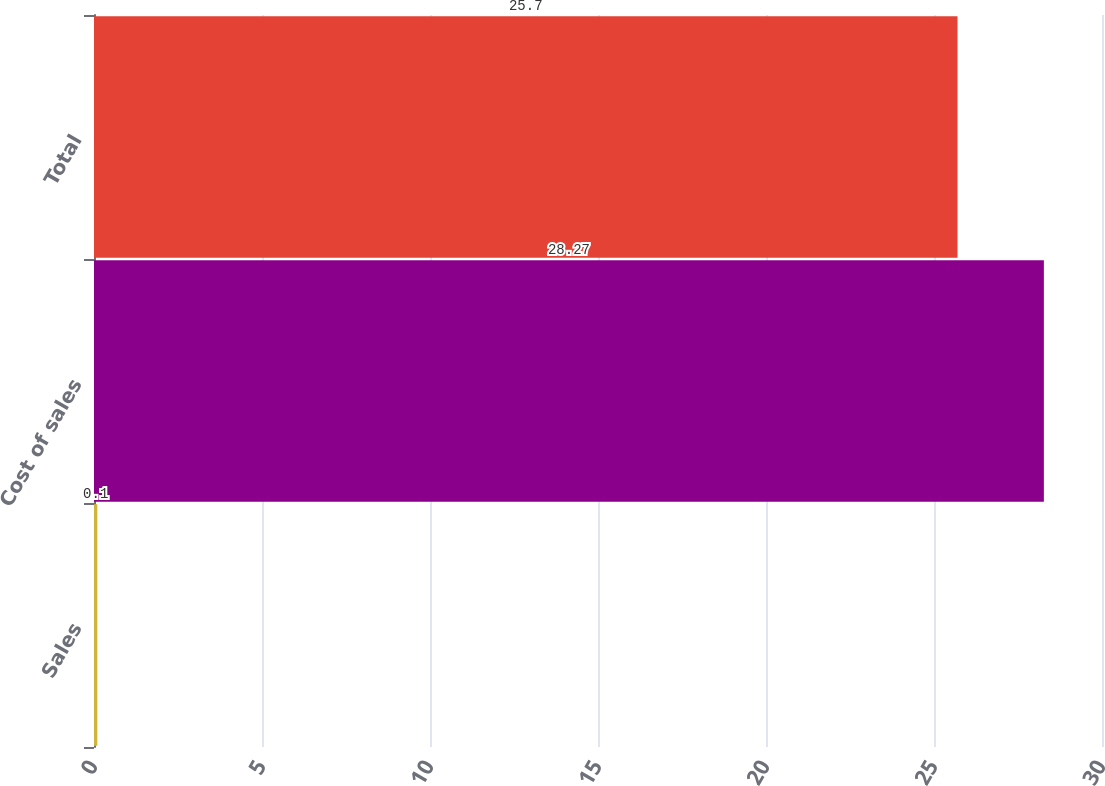Convert chart. <chart><loc_0><loc_0><loc_500><loc_500><bar_chart><fcel>Sales<fcel>Cost of sales<fcel>Total<nl><fcel>0.1<fcel>28.27<fcel>25.7<nl></chart> 